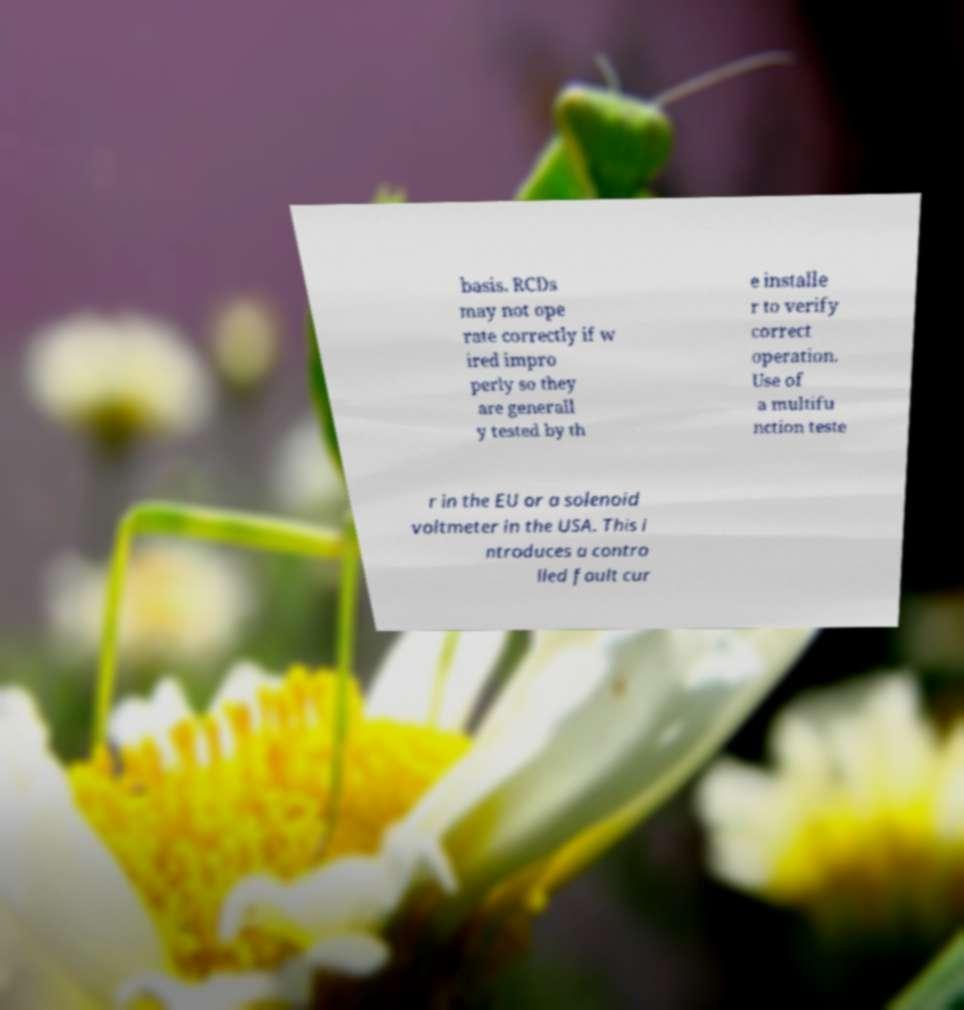What messages or text are displayed in this image? I need them in a readable, typed format. basis. RCDs may not ope rate correctly if w ired impro perly so they are generall y tested by th e installe r to verify correct operation. Use of a multifu nction teste r in the EU or a solenoid voltmeter in the USA. This i ntroduces a contro lled fault cur 